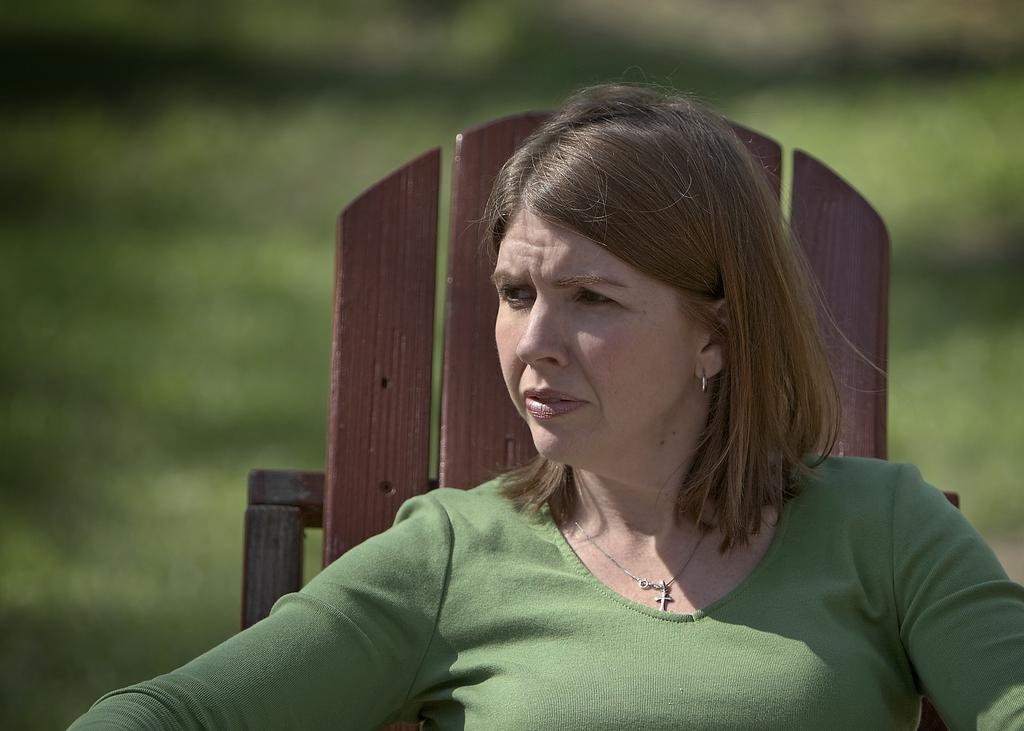What is the main subject of the image? The main subject of the image is a woman. What is the woman doing in the image? The woman is seated on a chair. What is the woman wearing in the image? The woman is wearing a green color T-shirt. What type of authority does the woman have in the image? There is no indication of any authority figure in the image; it simply shows a woman seated on a chair. What arithmetic problem is the woman solving in the image? There is no arithmetic problem visible in the image; it only shows a woman seated on a chair wearing a green color T-shirt. 